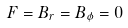Convert formula to latex. <formula><loc_0><loc_0><loc_500><loc_500>F = B _ { r } = B _ { \phi } = 0</formula> 